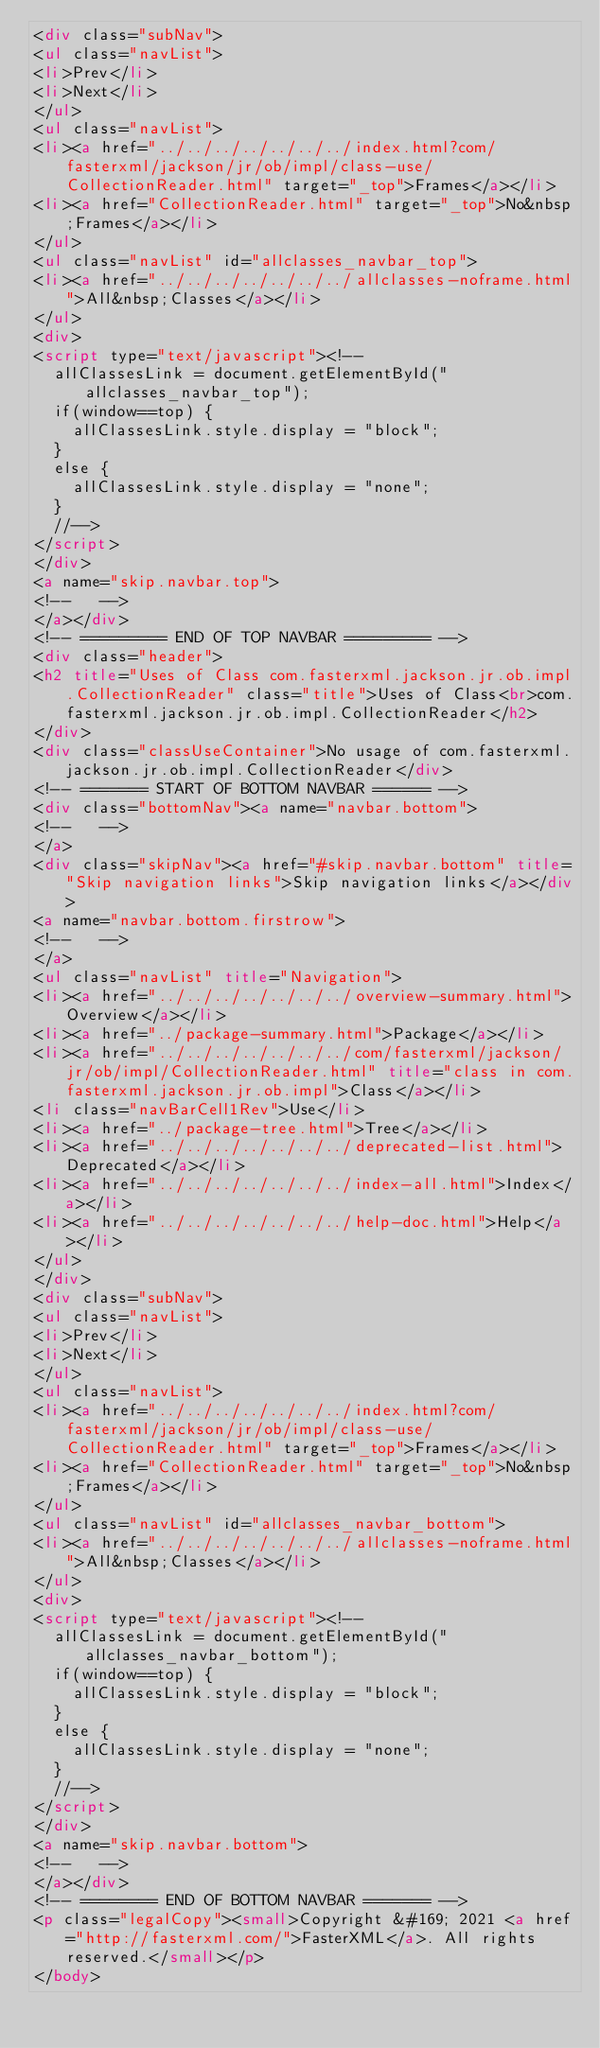<code> <loc_0><loc_0><loc_500><loc_500><_HTML_><div class="subNav">
<ul class="navList">
<li>Prev</li>
<li>Next</li>
</ul>
<ul class="navList">
<li><a href="../../../../../../../index.html?com/fasterxml/jackson/jr/ob/impl/class-use/CollectionReader.html" target="_top">Frames</a></li>
<li><a href="CollectionReader.html" target="_top">No&nbsp;Frames</a></li>
</ul>
<ul class="navList" id="allclasses_navbar_top">
<li><a href="../../../../../../../allclasses-noframe.html">All&nbsp;Classes</a></li>
</ul>
<div>
<script type="text/javascript"><!--
  allClassesLink = document.getElementById("allclasses_navbar_top");
  if(window==top) {
    allClassesLink.style.display = "block";
  }
  else {
    allClassesLink.style.display = "none";
  }
  //-->
</script>
</div>
<a name="skip.navbar.top">
<!--   -->
</a></div>
<!-- ========= END OF TOP NAVBAR ========= -->
<div class="header">
<h2 title="Uses of Class com.fasterxml.jackson.jr.ob.impl.CollectionReader" class="title">Uses of Class<br>com.fasterxml.jackson.jr.ob.impl.CollectionReader</h2>
</div>
<div class="classUseContainer">No usage of com.fasterxml.jackson.jr.ob.impl.CollectionReader</div>
<!-- ======= START OF BOTTOM NAVBAR ====== -->
<div class="bottomNav"><a name="navbar.bottom">
<!--   -->
</a>
<div class="skipNav"><a href="#skip.navbar.bottom" title="Skip navigation links">Skip navigation links</a></div>
<a name="navbar.bottom.firstrow">
<!--   -->
</a>
<ul class="navList" title="Navigation">
<li><a href="../../../../../../../overview-summary.html">Overview</a></li>
<li><a href="../package-summary.html">Package</a></li>
<li><a href="../../../../../../../com/fasterxml/jackson/jr/ob/impl/CollectionReader.html" title="class in com.fasterxml.jackson.jr.ob.impl">Class</a></li>
<li class="navBarCell1Rev">Use</li>
<li><a href="../package-tree.html">Tree</a></li>
<li><a href="../../../../../../../deprecated-list.html">Deprecated</a></li>
<li><a href="../../../../../../../index-all.html">Index</a></li>
<li><a href="../../../../../../../help-doc.html">Help</a></li>
</ul>
</div>
<div class="subNav">
<ul class="navList">
<li>Prev</li>
<li>Next</li>
</ul>
<ul class="navList">
<li><a href="../../../../../../../index.html?com/fasterxml/jackson/jr/ob/impl/class-use/CollectionReader.html" target="_top">Frames</a></li>
<li><a href="CollectionReader.html" target="_top">No&nbsp;Frames</a></li>
</ul>
<ul class="navList" id="allclasses_navbar_bottom">
<li><a href="../../../../../../../allclasses-noframe.html">All&nbsp;Classes</a></li>
</ul>
<div>
<script type="text/javascript"><!--
  allClassesLink = document.getElementById("allclasses_navbar_bottom");
  if(window==top) {
    allClassesLink.style.display = "block";
  }
  else {
    allClassesLink.style.display = "none";
  }
  //-->
</script>
</div>
<a name="skip.navbar.bottom">
<!--   -->
</a></div>
<!-- ======== END OF BOTTOM NAVBAR ======= -->
<p class="legalCopy"><small>Copyright &#169; 2021 <a href="http://fasterxml.com/">FasterXML</a>. All rights reserved.</small></p>
</body></code> 